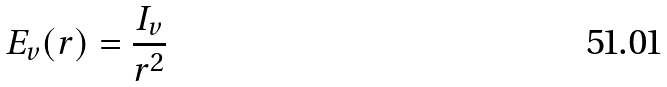<formula> <loc_0><loc_0><loc_500><loc_500>E _ { v } ( r ) = \frac { I _ { v } } { r ^ { 2 } }</formula> 